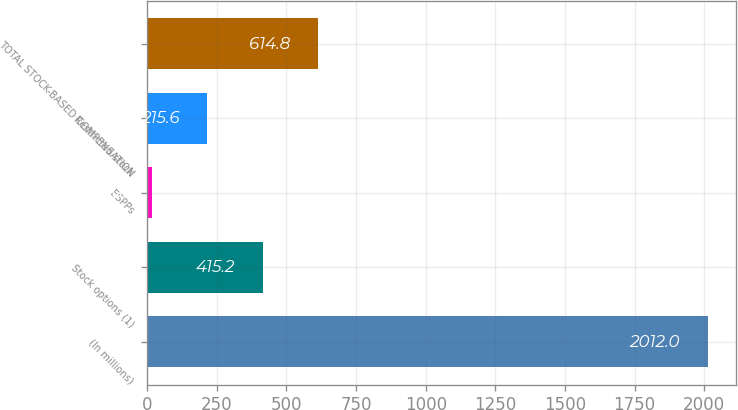<chart> <loc_0><loc_0><loc_500><loc_500><bar_chart><fcel>(In millions)<fcel>Stock options (1)<fcel>ESPPs<fcel>Restricted stock<fcel>TOTAL STOCK-BASED COMPENSATION<nl><fcel>2012<fcel>415.2<fcel>16<fcel>215.6<fcel>614.8<nl></chart> 